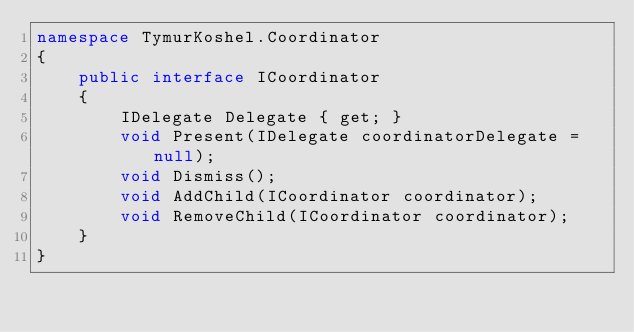<code> <loc_0><loc_0><loc_500><loc_500><_C#_>namespace TymurKoshel.Coordinator
{
    public interface ICoordinator
    {
        IDelegate Delegate { get; }
        void Present(IDelegate coordinatorDelegate = null);
        void Dismiss();
        void AddChild(ICoordinator coordinator);
        void RemoveChild(ICoordinator coordinator);
    }
}</code> 